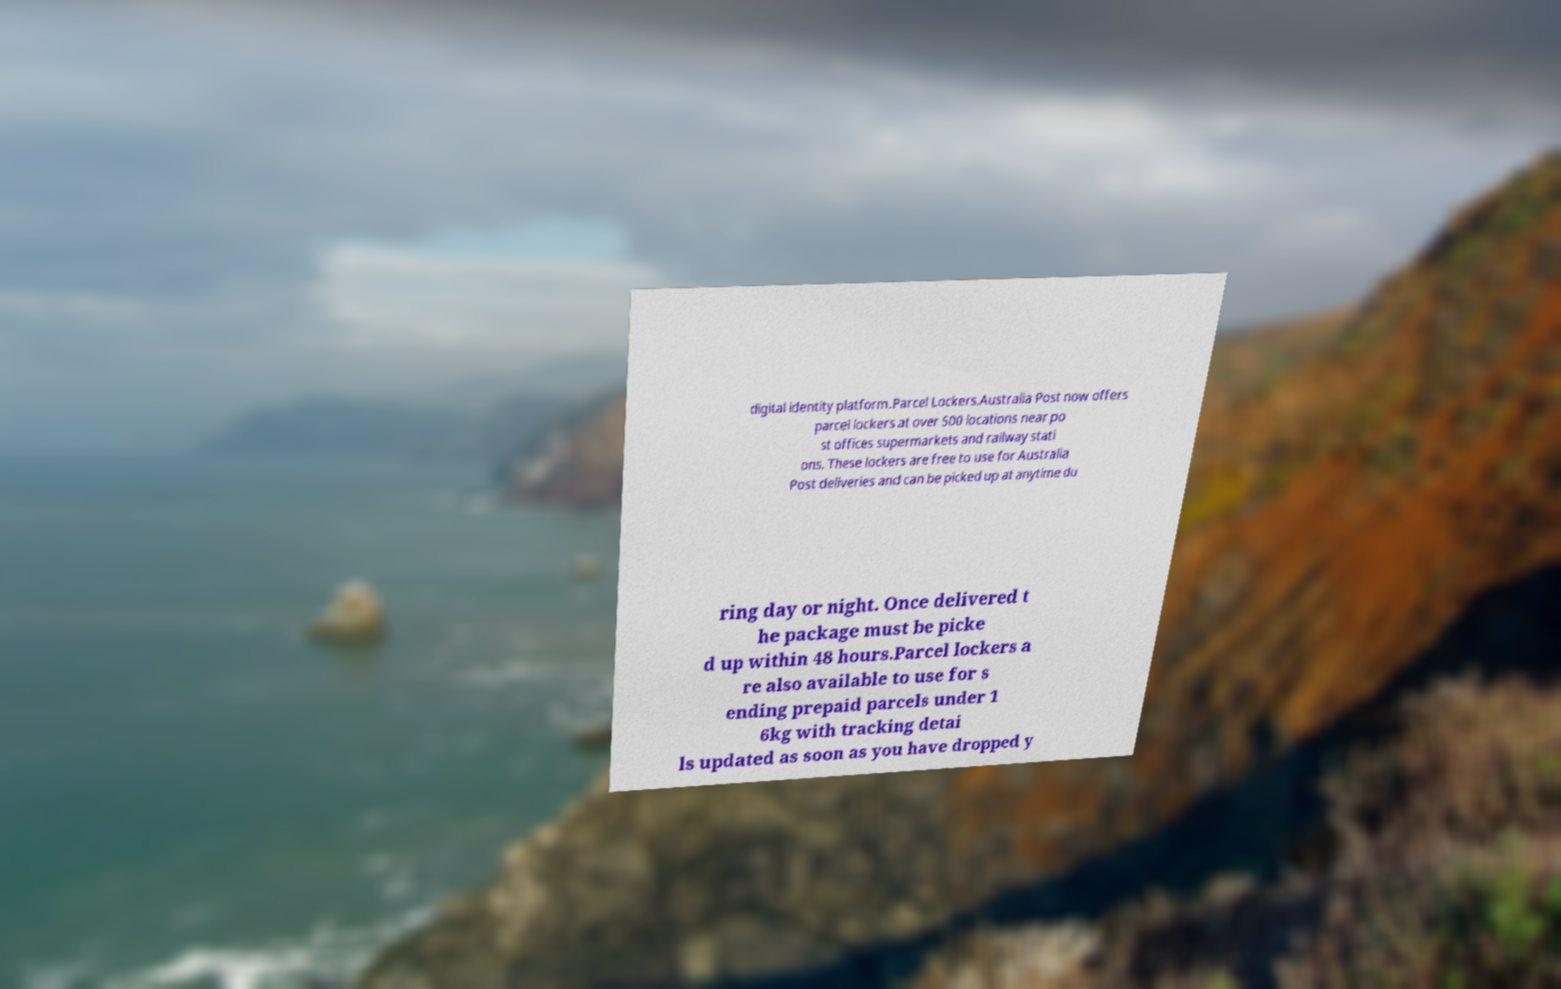Could you extract and type out the text from this image? digital identity platform.Parcel Lockers.Australia Post now offers parcel lockers at over 500 locations near po st offices supermarkets and railway stati ons. These lockers are free to use for Australia Post deliveries and can be picked up at anytime du ring day or night. Once delivered t he package must be picke d up within 48 hours.Parcel lockers a re also available to use for s ending prepaid parcels under 1 6kg with tracking detai ls updated as soon as you have dropped y 